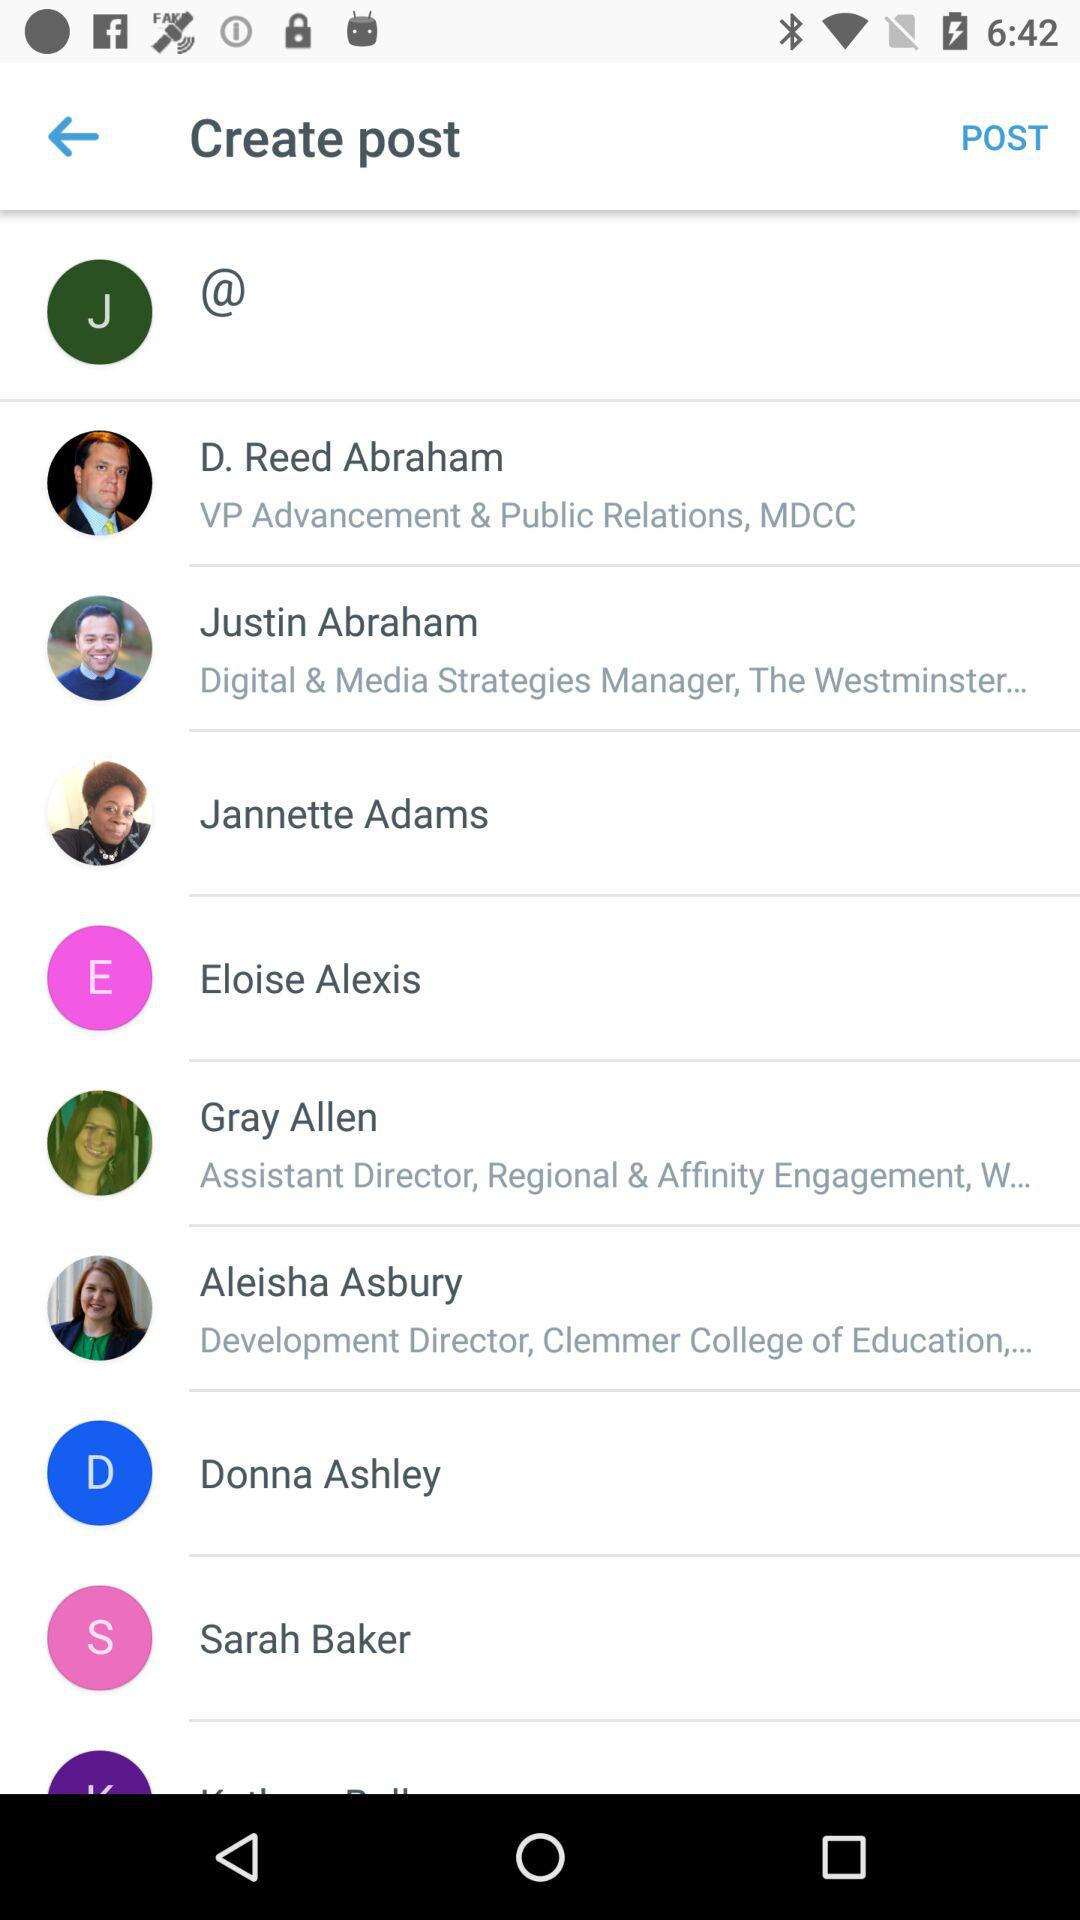Who is the digital and media strategy manager? The digital and media strategy manager is Justin Abraham. 